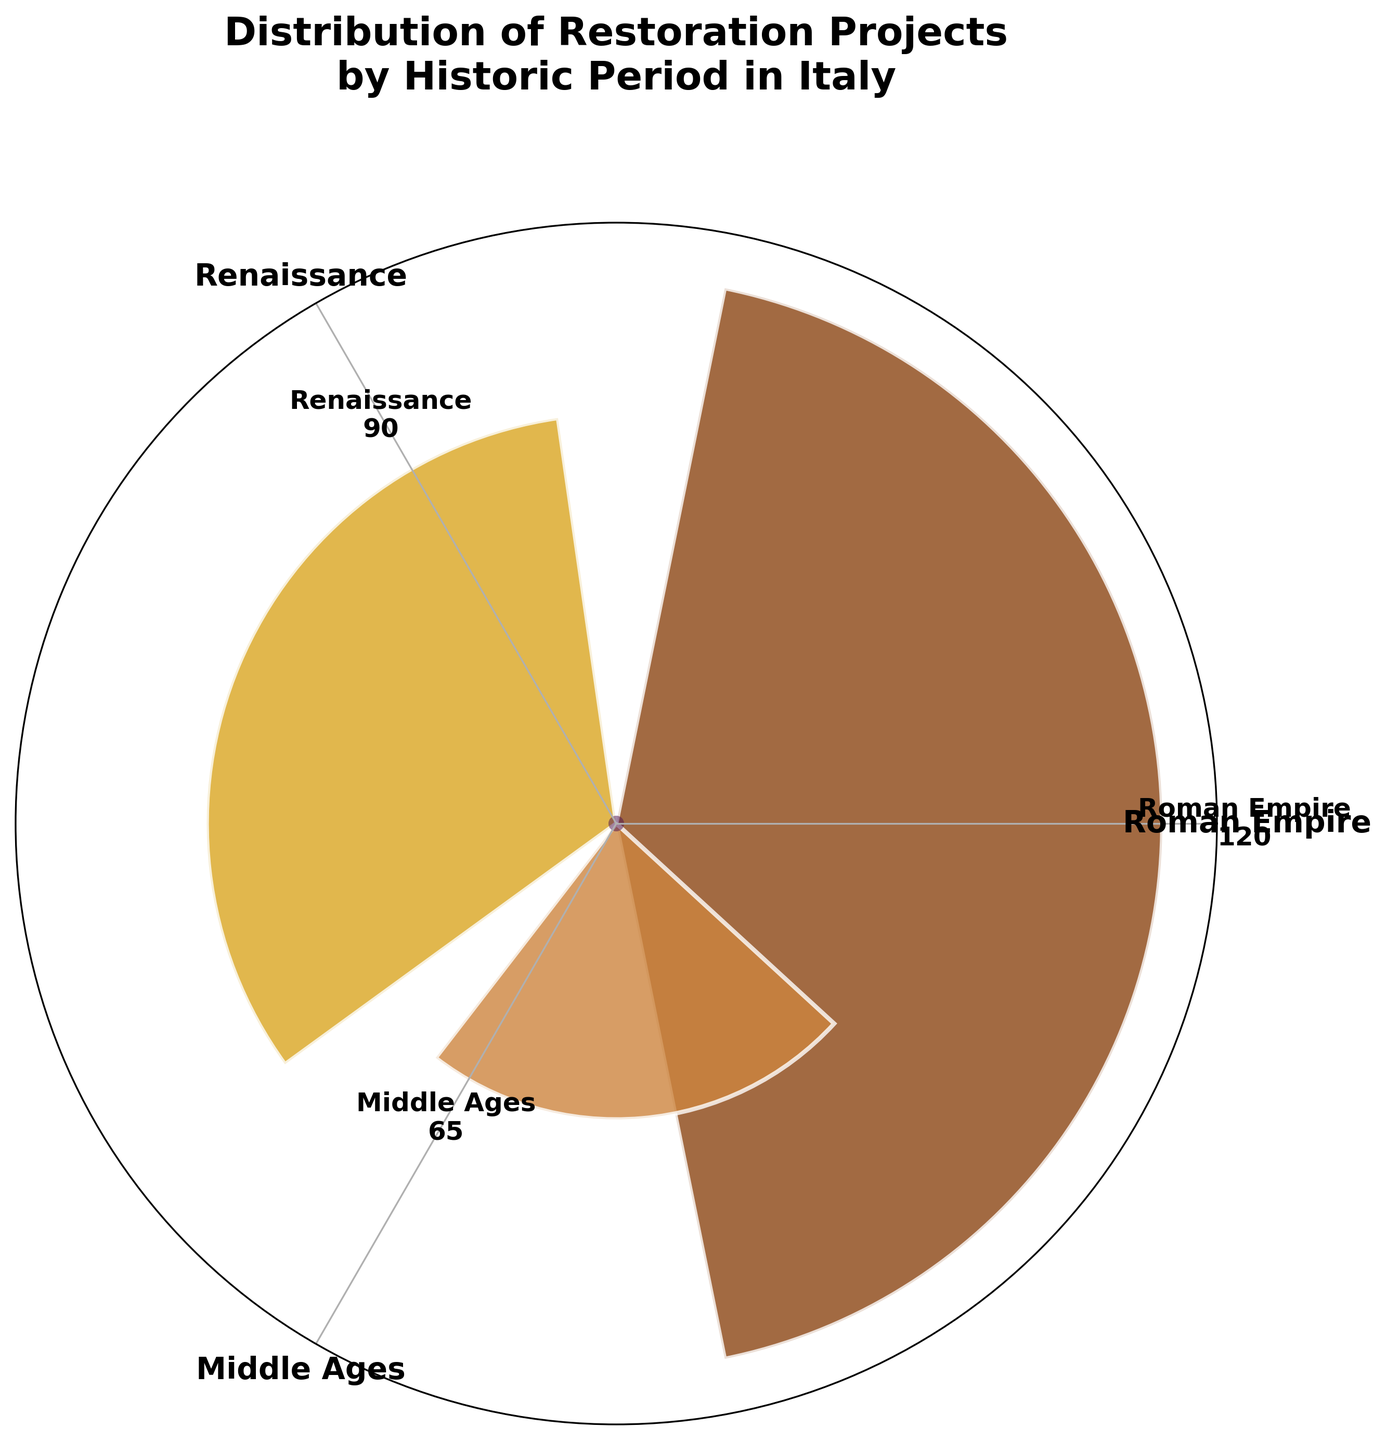What is the title of the rose chart? The title is prominently displayed at the top of the chart. It reads "Distribution of Restoration Projects by Historic Period in Italy."
Answer: Distribution of Restoration Projects by Historic Period in Italy Which historic period has the most restoration projects? Each period is labeled with its name and corresponding number of projects. The highest value is associated with the Roman Empire, which has 120 projects.
Answer: Roman Empire How many periods are represented in the rose chart? The chart includes labels for the top three periods based on the number of projects. Counting these labels, we see three periods represented.
Answer: 3 What is the cumulative number of projects for the Renaissance and Modern Era periods? The chart shows the number of projects for the Renaissance (90) and Modern Era (45). Adding these numbers gives 90 + 45 = 135.
Answer: 135 What percentage of the total top three restoration projects are from the Middle Ages period? The total number of projects for the top three periods is 120 (Roman Empire) + 90 (Renaissance) + 65 (Middle Ages) = 275. The Middle Ages projects account for 65 projects. The percentage is calculated as (65 / 275) * 100 ≈ 23.64%.
Answer: 23.64% Which period has the smallest slice in the rose chart? The chart depicts slices with varying angles, representing each period's proportion. The slice for the Modern Era is the smallest, indicating it has the least projects.
Answer: Modern Era Compare the restoration projects between the period with the second-highest projects and the period with the fewest projects. The second-highest is the Renaissance (90 projects) and the fewest is the Modern Era (45 projects). The difference is 90 - 45 = 45 projects.
Answer: 45 projects How are the restoration projects distributed among the periods shown in the rose chart? The Roman Empire, Renaissance, and Middle Ages are represented in descending order of projects. The chart shows the relative sizes of their contributions through colored slices.
Answer: Roman Empire > Renaissance > Middle Ages What is the average number of projects for the top three periods? There are 275 projects in total for the top three periods. The average number is calculated as 275 / 3 ≈ 91.67.
Answer: 91.67 